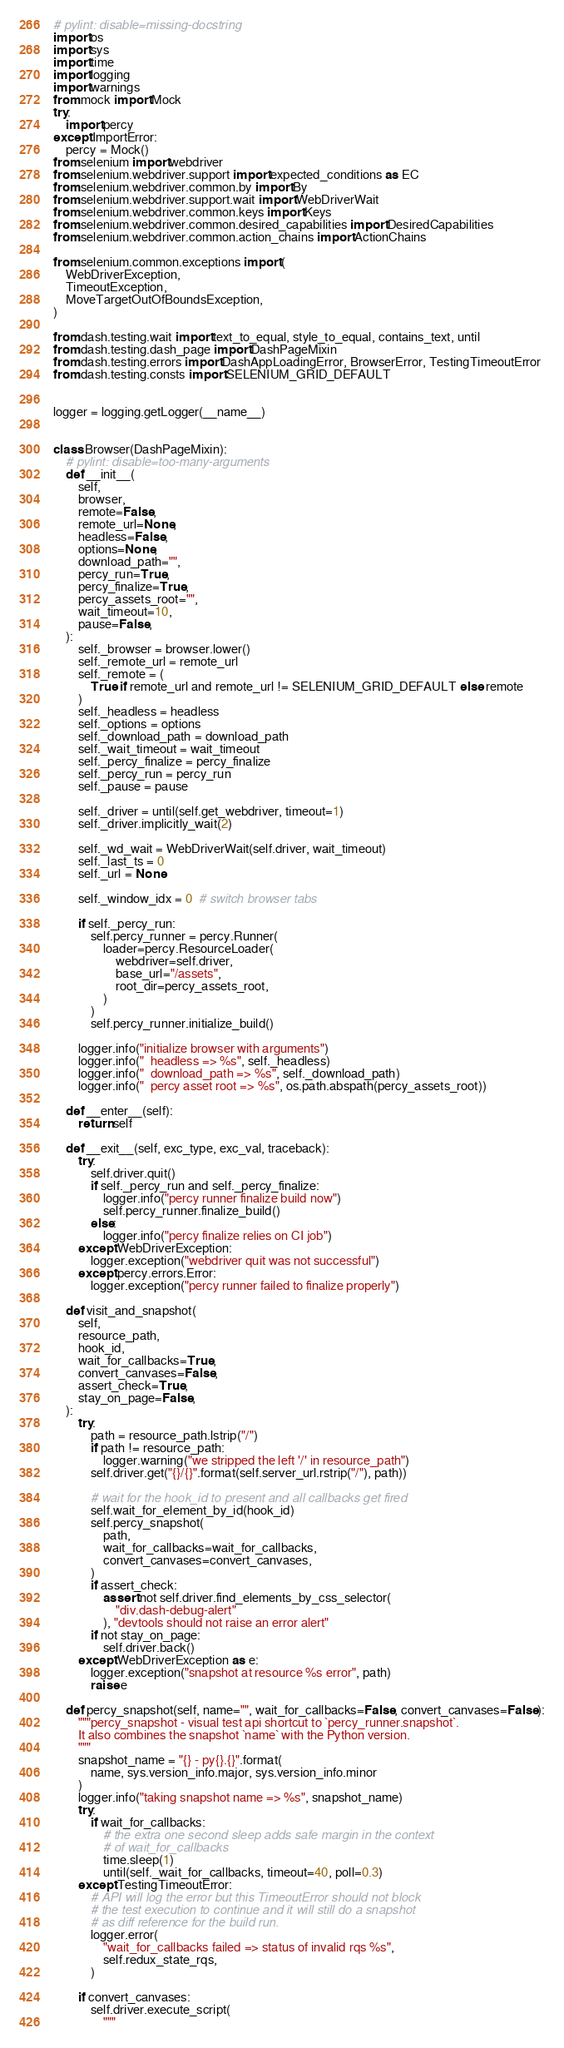Convert code to text. <code><loc_0><loc_0><loc_500><loc_500><_Python_># pylint: disable=missing-docstring
import os
import sys
import time
import logging
import warnings
from mock import Mock
try:
    import percy
except ImportError:
    percy = Mock()
from selenium import webdriver
from selenium.webdriver.support import expected_conditions as EC
from selenium.webdriver.common.by import By
from selenium.webdriver.support.wait import WebDriverWait
from selenium.webdriver.common.keys import Keys
from selenium.webdriver.common.desired_capabilities import DesiredCapabilities
from selenium.webdriver.common.action_chains import ActionChains

from selenium.common.exceptions import (
    WebDriverException,
    TimeoutException,
    MoveTargetOutOfBoundsException,
)

from dash.testing.wait import text_to_equal, style_to_equal, contains_text, until
from dash.testing.dash_page import DashPageMixin
from dash.testing.errors import DashAppLoadingError, BrowserError, TestingTimeoutError
from dash.testing.consts import SELENIUM_GRID_DEFAULT


logger = logging.getLogger(__name__)


class Browser(DashPageMixin):
    # pylint: disable=too-many-arguments
    def __init__(
        self,
        browser,
        remote=False,
        remote_url=None,
        headless=False,
        options=None,
        download_path="",
        percy_run=True,
        percy_finalize=True,
        percy_assets_root="",
        wait_timeout=10,
        pause=False,
    ):
        self._browser = browser.lower()
        self._remote_url = remote_url
        self._remote = (
            True if remote_url and remote_url != SELENIUM_GRID_DEFAULT else remote
        )
        self._headless = headless
        self._options = options
        self._download_path = download_path
        self._wait_timeout = wait_timeout
        self._percy_finalize = percy_finalize
        self._percy_run = percy_run
        self._pause = pause

        self._driver = until(self.get_webdriver, timeout=1)
        self._driver.implicitly_wait(2)

        self._wd_wait = WebDriverWait(self.driver, wait_timeout)
        self._last_ts = 0
        self._url = None

        self._window_idx = 0  # switch browser tabs

        if self._percy_run:
            self.percy_runner = percy.Runner(
                loader=percy.ResourceLoader(
                    webdriver=self.driver,
                    base_url="/assets",
                    root_dir=percy_assets_root,
                )
            )
            self.percy_runner.initialize_build()

        logger.info("initialize browser with arguments")
        logger.info("  headless => %s", self._headless)
        logger.info("  download_path => %s", self._download_path)
        logger.info("  percy asset root => %s", os.path.abspath(percy_assets_root))

    def __enter__(self):
        return self

    def __exit__(self, exc_type, exc_val, traceback):
        try:
            self.driver.quit()
            if self._percy_run and self._percy_finalize:
                logger.info("percy runner finalize build now")
                self.percy_runner.finalize_build()
            else:
                logger.info("percy finalize relies on CI job")
        except WebDriverException:
            logger.exception("webdriver quit was not successful")
        except percy.errors.Error:
            logger.exception("percy runner failed to finalize properly")

    def visit_and_snapshot(
        self,
        resource_path,
        hook_id,
        wait_for_callbacks=True,
        convert_canvases=False,
        assert_check=True,
        stay_on_page=False,
    ):
        try:
            path = resource_path.lstrip("/")
            if path != resource_path:
                logger.warning("we stripped the left '/' in resource_path")
            self.driver.get("{}/{}".format(self.server_url.rstrip("/"), path))

            # wait for the hook_id to present and all callbacks get fired
            self.wait_for_element_by_id(hook_id)
            self.percy_snapshot(
                path,
                wait_for_callbacks=wait_for_callbacks,
                convert_canvases=convert_canvases,
            )
            if assert_check:
                assert not self.driver.find_elements_by_css_selector(
                    "div.dash-debug-alert"
                ), "devtools should not raise an error alert"
            if not stay_on_page:
                self.driver.back()
        except WebDriverException as e:
            logger.exception("snapshot at resource %s error", path)
            raise e

    def percy_snapshot(self, name="", wait_for_callbacks=False, convert_canvases=False):
        """percy_snapshot - visual test api shortcut to `percy_runner.snapshot`.
        It also combines the snapshot `name` with the Python version.
        """
        snapshot_name = "{} - py{}.{}".format(
            name, sys.version_info.major, sys.version_info.minor
        )
        logger.info("taking snapshot name => %s", snapshot_name)
        try:
            if wait_for_callbacks:
                # the extra one second sleep adds safe margin in the context
                # of wait_for_callbacks
                time.sleep(1)
                until(self._wait_for_callbacks, timeout=40, poll=0.3)
        except TestingTimeoutError:
            # API will log the error but this TimeoutError should not block
            # the test execution to continue and it will still do a snapshot
            # as diff reference for the build run.
            logger.error(
                "wait_for_callbacks failed => status of invalid rqs %s",
                self.redux_state_rqs,
            )

        if convert_canvases:
            self.driver.execute_script(
                """</code> 